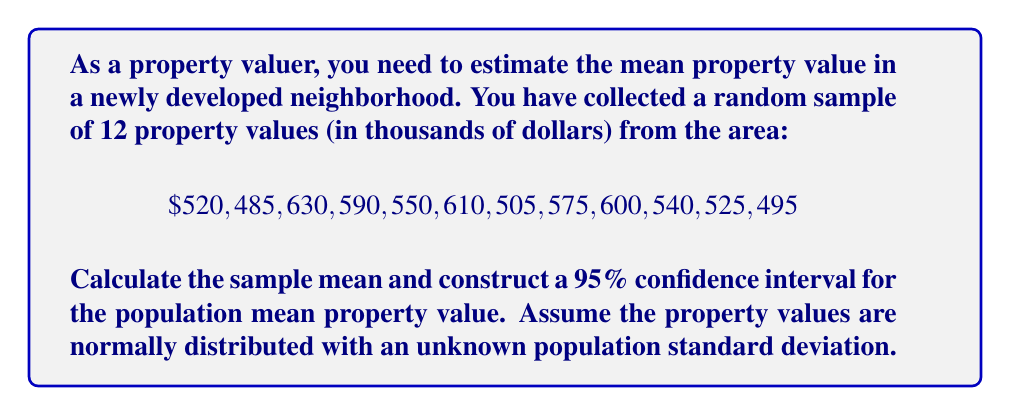Give your solution to this math problem. To solve this problem, we'll follow these steps:

1. Calculate the sample mean
2. Calculate the sample standard deviation
3. Determine the t-value for a 95% confidence interval
4. Calculate the margin of error
5. Construct the confidence interval

Step 1: Calculate the sample mean
The sample mean is given by the formula:
$$\bar{x} = \frac{\sum_{i=1}^{n} x_i}{n}$$

Sum of all values: $520 + 485 + 630 + 590 + 550 + 610 + 505 + 575 + 600 + 540 + 525 + 495 = 6625$

Sample size: $n = 12$

$$\bar{x} = \frac{6625}{12} = 552.0833$$

Step 2: Calculate the sample standard deviation
The sample standard deviation is given by the formula:
$$s = \sqrt{\frac{\sum_{i=1}^{n} (x_i - \bar{x})^2}{n - 1}}$$

Calculating $(x_i - \bar{x})^2$ for each value and summing:

$$(520 - 552.0833)^2 + ... + (495 - 552.0833)^2 = 39,739.5833$$

$$s = \sqrt{\frac{39,739.5833}{11}} = 60.0788$$

Step 3: Determine the t-value
For a 95% confidence interval with 11 degrees of freedom (n - 1), the t-value is 2.201 (from t-distribution table).

Step 4: Calculate the margin of error
The margin of error is given by:
$$\text{ME} = t_{\alpha/2, n-1} \cdot \frac{s}{\sqrt{n}}$$

$$\text{ME} = 2.201 \cdot \frac{60.0788}{\sqrt{12}} = 38.1499$$

Step 5: Construct the confidence interval
The confidence interval is given by:
$$(\bar{x} - \text{ME}, \bar{x} + \text{ME})$$

$$(552.0833 - 38.1499, 552.0833 + 38.1499)$$
$$(513.9334, 590.2332)$$
Answer: The sample mean property value is $552.0833 thousand, and the 95% confidence interval for the population mean property value is ($513.9334, $590.2332) thousand. 